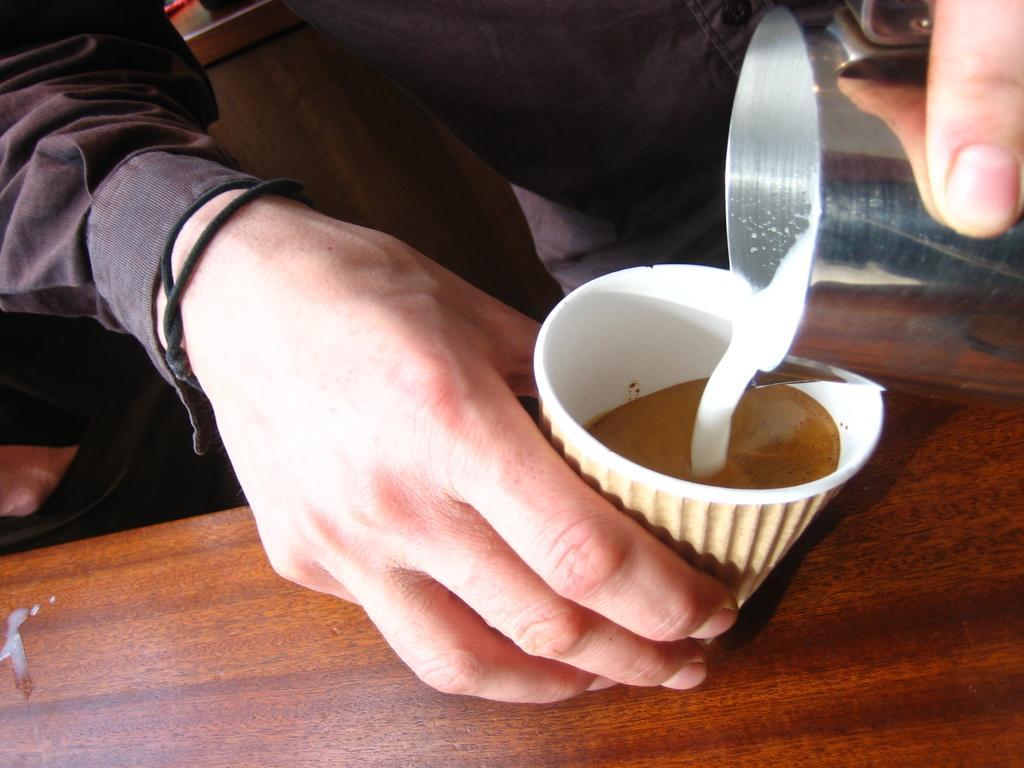Please provide a concise description of this image. Bottom right side of the image there is a table, On the table there is a cup. Top right side of the image there is a person standing and holding a glass. 